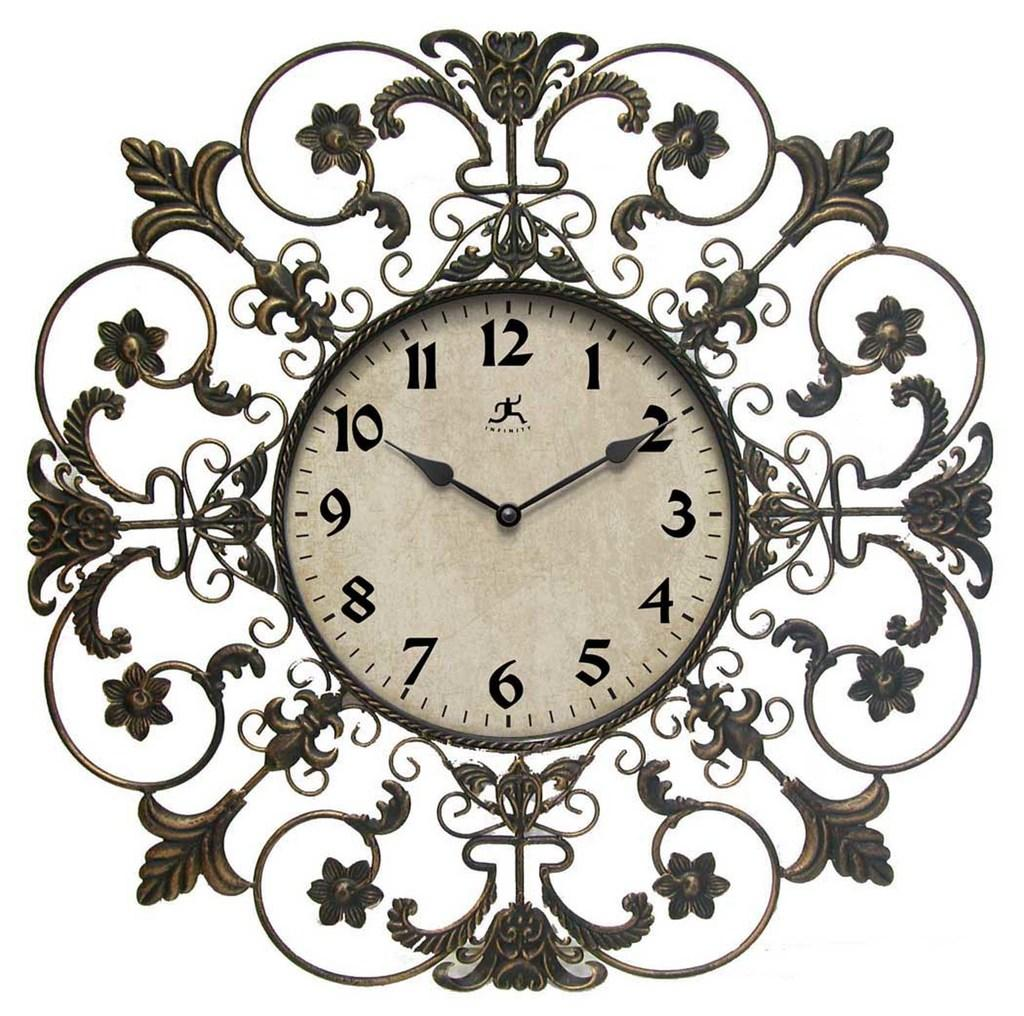<image>
Give a short and clear explanation of the subsequent image. A very ornately designed clock is showing it's 10:10 with INFINITY on it. 